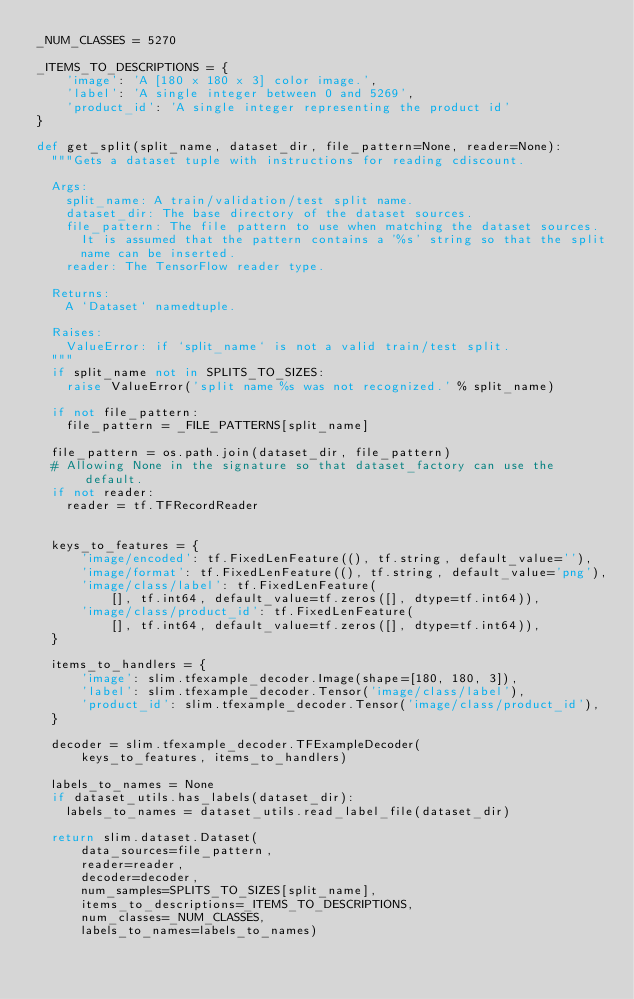Convert code to text. <code><loc_0><loc_0><loc_500><loc_500><_Python_>_NUM_CLASSES = 5270

_ITEMS_TO_DESCRIPTIONS = {
    'image': 'A [180 x 180 x 3] color image.',
    'label': 'A single integer between 0 and 5269',
    'product_id': 'A single integer representing the product id'
}

def get_split(split_name, dataset_dir, file_pattern=None, reader=None):
  """Gets a dataset tuple with instructions for reading cdiscount.

  Args:
    split_name: A train/validation/test split name.
    dataset_dir: The base directory of the dataset sources.
    file_pattern: The file pattern to use when matching the dataset sources.
      It is assumed that the pattern contains a '%s' string so that the split
      name can be inserted.
    reader: The TensorFlow reader type.

  Returns:
    A `Dataset` namedtuple.

  Raises:
    ValueError: if `split_name` is not a valid train/test split.
  """
  if split_name not in SPLITS_TO_SIZES:
    raise ValueError('split name %s was not recognized.' % split_name)

  if not file_pattern:
    file_pattern = _FILE_PATTERNS[split_name]

  file_pattern = os.path.join(dataset_dir, file_pattern)
  # Allowing None in the signature so that dataset_factory can use the default.
  if not reader:
    reader = tf.TFRecordReader


  keys_to_features = {
      'image/encoded': tf.FixedLenFeature((), tf.string, default_value=''),
      'image/format': tf.FixedLenFeature((), tf.string, default_value='png'),
      'image/class/label': tf.FixedLenFeature(
          [], tf.int64, default_value=tf.zeros([], dtype=tf.int64)),
      'image/class/product_id': tf.FixedLenFeature(
          [], tf.int64, default_value=tf.zeros([], dtype=tf.int64)),
  }

  items_to_handlers = {
      'image': slim.tfexample_decoder.Image(shape=[180, 180, 3]),
      'label': slim.tfexample_decoder.Tensor('image/class/label'),
      'product_id': slim.tfexample_decoder.Tensor('image/class/product_id'),
  }

  decoder = slim.tfexample_decoder.TFExampleDecoder(
      keys_to_features, items_to_handlers)

  labels_to_names = None
  if dataset_utils.has_labels(dataset_dir):
    labels_to_names = dataset_utils.read_label_file(dataset_dir)

  return slim.dataset.Dataset(
      data_sources=file_pattern,
      reader=reader,
      decoder=decoder,
      num_samples=SPLITS_TO_SIZES[split_name],
      items_to_descriptions=_ITEMS_TO_DESCRIPTIONS,
      num_classes=_NUM_CLASSES,
      labels_to_names=labels_to_names)</code> 